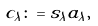<formula> <loc_0><loc_0><loc_500><loc_500>c _ { \lambda } \colon = s _ { \lambda } a _ { \lambda } ,</formula> 